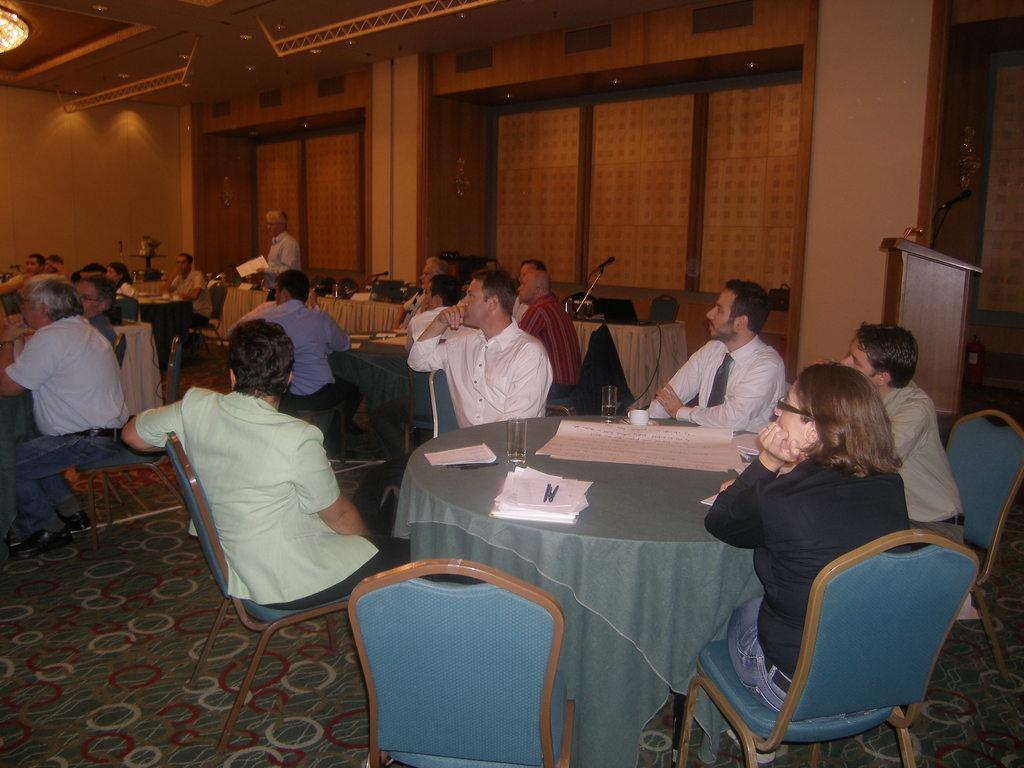What are the people in the image doing? There is a group of people sitting on chairs. What objects can be seen on the table? There is a glass, a paper, a pen, and a cup on the table. Is there any furniture or structure at the back side of the image? Yes, there is a podium at the back side. What type of coal is being used to fuel the laughter in the image? There is no coal or laughter present in the image. Is there a pin visible on the table in the image? The provided facts do not mention a pin, so we cannot determine if there is one present in the image. 